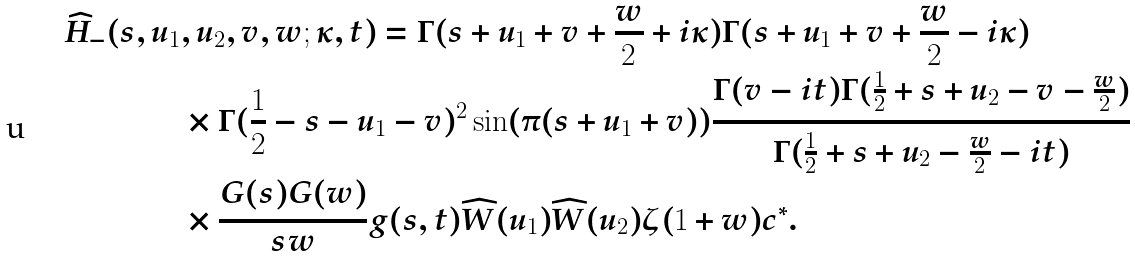<formula> <loc_0><loc_0><loc_500><loc_500>\widehat { H } _ { - } ( s , u _ { 1 } & , u _ { 2 } , v , w ; \kappa , t ) = \Gamma ( s + u _ { 1 } + v + \frac { w } { 2 } + i \kappa ) \Gamma ( s + u _ { 1 } + v + \frac { w } { 2 } - i \kappa ) \\ & \times \Gamma ( \frac { 1 } { 2 } - s - u _ { 1 } - v ) ^ { 2 } \sin ( \pi ( s + u _ { 1 } + v ) ) \frac { \Gamma ( v - i t ) \Gamma ( \frac { 1 } { 2 } + s + u _ { 2 } - v - \frac { w } { 2 } ) } { \Gamma ( \frac { 1 } { 2 } + s + u _ { 2 } - \frac { w } { 2 } - i t ) } \\ & \times \frac { G ( s ) G ( w ) } { s w } g ( s , t ) \widehat { W } ( u _ { 1 } ) \widehat { W } ( u _ { 2 } ) \zeta ( 1 + w ) c ^ { * } .</formula> 